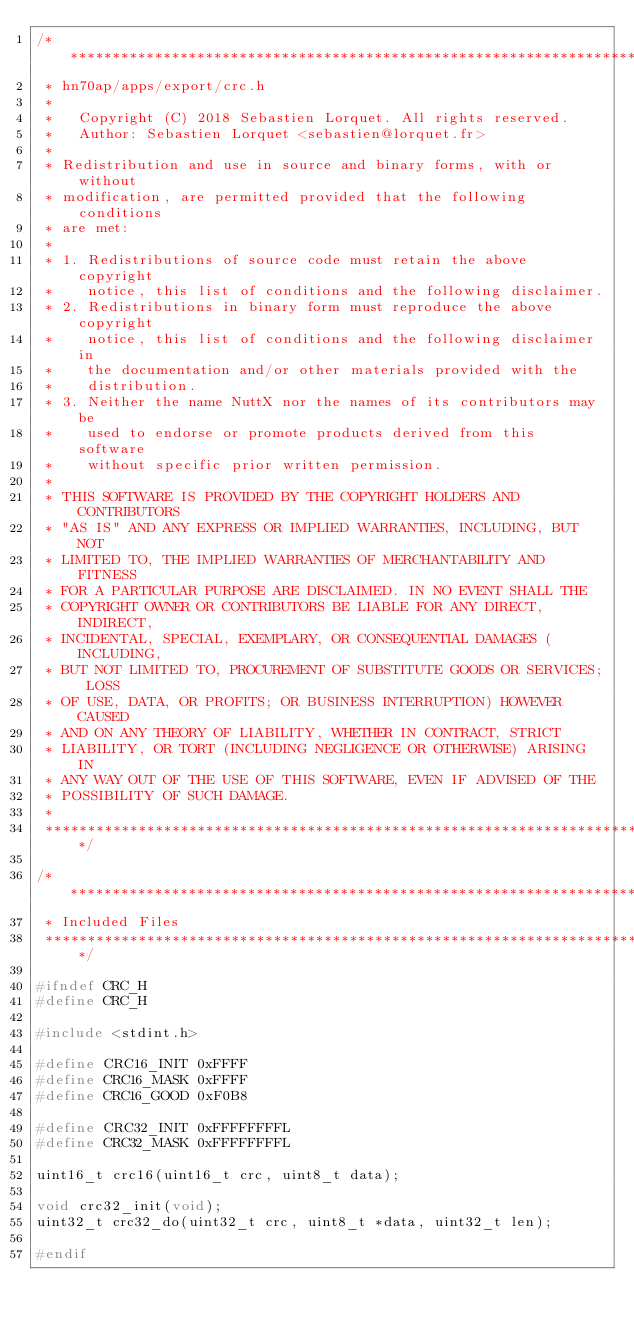<code> <loc_0><loc_0><loc_500><loc_500><_C_>/****************************************************************************
 * hn70ap/apps/export/crc.h
 *
 *   Copyright (C) 2018 Sebastien Lorquet. All rights reserved.
 *   Author: Sebastien Lorquet <sebastien@lorquet.fr>
 *
 * Redistribution and use in source and binary forms, with or without
 * modification, are permitted provided that the following conditions
 * are met:
 *
 * 1. Redistributions of source code must retain the above copyright
 *    notice, this list of conditions and the following disclaimer.
 * 2. Redistributions in binary form must reproduce the above copyright
 *    notice, this list of conditions and the following disclaimer in
 *    the documentation and/or other materials provided with the
 *    distribution.
 * 3. Neither the name NuttX nor the names of its contributors may be
 *    used to endorse or promote products derived from this software
 *    without specific prior written permission.
 *
 * THIS SOFTWARE IS PROVIDED BY THE COPYRIGHT HOLDERS AND CONTRIBUTORS
 * "AS IS" AND ANY EXPRESS OR IMPLIED WARRANTIES, INCLUDING, BUT NOT
 * LIMITED TO, THE IMPLIED WARRANTIES OF MERCHANTABILITY AND FITNESS
 * FOR A PARTICULAR PURPOSE ARE DISCLAIMED. IN NO EVENT SHALL THE
 * COPYRIGHT OWNER OR CONTRIBUTORS BE LIABLE FOR ANY DIRECT, INDIRECT,
 * INCIDENTAL, SPECIAL, EXEMPLARY, OR CONSEQUENTIAL DAMAGES (INCLUDING,
 * BUT NOT LIMITED TO, PROCUREMENT OF SUBSTITUTE GOODS OR SERVICES; LOSS
 * OF USE, DATA, OR PROFITS; OR BUSINESS INTERRUPTION) HOWEVER CAUSED
 * AND ON ANY THEORY OF LIABILITY, WHETHER IN CONTRACT, STRICT
 * LIABILITY, OR TORT (INCLUDING NEGLIGENCE OR OTHERWISE) ARISING IN
 * ANY WAY OUT OF THE USE OF THIS SOFTWARE, EVEN IF ADVISED OF THE
 * POSSIBILITY OF SUCH DAMAGE.
 *
 ****************************************************************************/

/****************************************************************************
 * Included Files
 ****************************************************************************/

#ifndef CRC_H
#define CRC_H

#include <stdint.h>

#define CRC16_INIT 0xFFFF
#define CRC16_MASK 0xFFFF
#define CRC16_GOOD 0xF0B8

#define CRC32_INIT 0xFFFFFFFFL
#define CRC32_MASK 0xFFFFFFFFL

uint16_t crc16(uint16_t crc, uint8_t data);

void crc32_init(void);
uint32_t crc32_do(uint32_t crc, uint8_t *data, uint32_t len);

#endif
</code> 